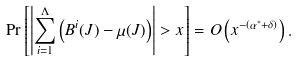Convert formula to latex. <formula><loc_0><loc_0><loc_500><loc_500>\Pr \left [ \left | \sum _ { i = 1 } ^ { \Lambda } \left ( B ^ { i } ( J ) - \mu ( J ) \right ) \right | > x \right ] = O \left ( x ^ { - ( \alpha ^ { \ast } + \delta ) } \right ) .</formula> 